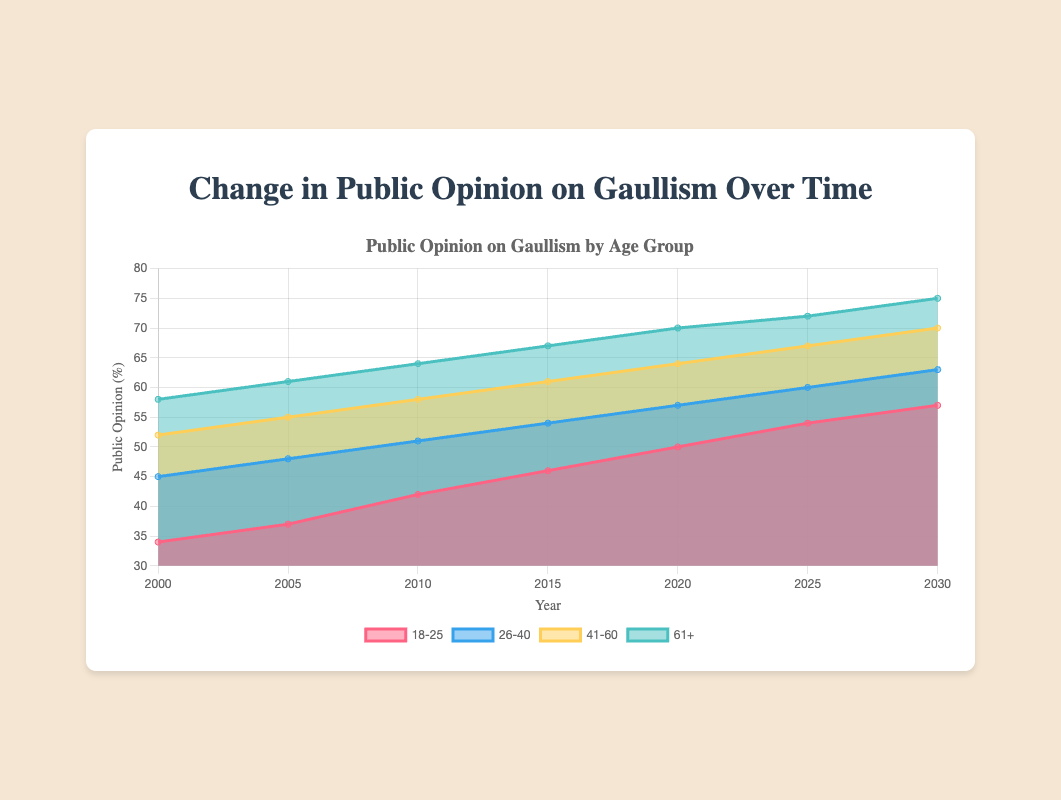What's the title of the figure? The title of the figure can be read directly from the top of the chart area.
Answer: Change in Public Opinion on Gaullism Over Time What does the x-axis represent? The x-axis typically labels the horizontal dimension of a plot. In this case, it represents the different years from 2000 to 2030.
Answer: Year What does the y-axis represent? The y-axis typically labels the vertical dimension of a plot. In this figure, it represents the public opinion in percentages.
Answer: Public Opinion (%) In which year did the '18-25' age group have the lowest opinion on Gaullism? To find this, look at the '18-25' data points plotted over time. The lowest value is at year 2000 with 34%.
Answer: 2000 How many data points are there for each age group? By counting the years labeled on the x-axis, we can see that there are 7 data points for each age group from 2000 to 2030.
Answer: 7 What is the public opinion percentage for the '26-40' age group in 2025? By looking at the data point for the '26-40' age group at the year 2025, we can see it is 60%.
Answer: 60% Which age group has the highest public opinion percentage in 2010? By comparing the data points for all age groups at the year 2010, the '61+' group has the highest value, which is 64%.
Answer: 61+ Calculate the difference in public opinion between the '41-60' and '61+' age groups in 2020. Subtract the '41-60' value from the '61+' value in 2020: 70 - 64 = 6%.
Answer: 6% What trend do you notice for the '18-25' age group from 2000 to 2030? Observing the data trend for the '18-25' group, there is a consistent increase in public opinion from 34% to 57% over these years.
Answer: Increasing Compare the public opinion changes from 2000 to 2030 across all age groups. What do you observe? Each age group shows an increasing trend in public opinion over time. The '61+' group remains the highest throughout, and the '18-25' group has the most substantial relative increase.
Answer: All increasing What is the average public opinion percentage for the '41-60' age group across all the years? Sum the values (52 + 55 + 58 + 61 + 64 + 67 + 70) and then divide by the number of years (7): (427/7) = 61%.
Answer: 61% 